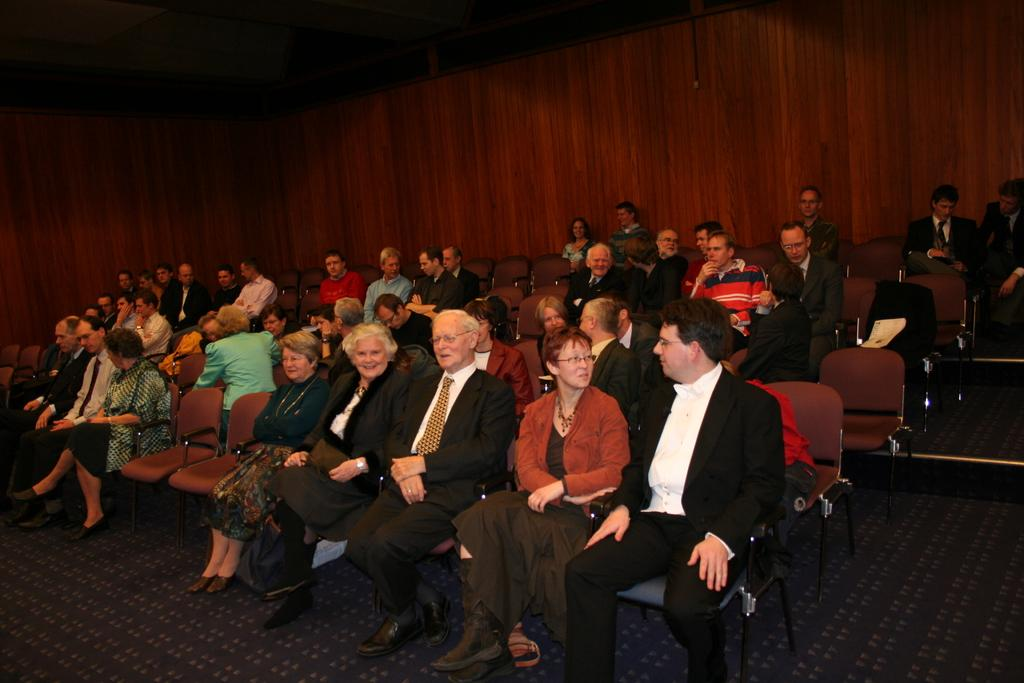What are the people in the image doing? The people in the image are sitting on chairs. Can you describe the background of the image? There is a wooden wall in the background of the image. How many frogs are sitting on the chairs in the image? There are no frogs present in the image; it features people sitting on chairs. What type of slavery is depicted in the image? There is no depiction of slavery in the image; it simply shows people sitting on chairs in front of a wooden wall. 